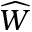<formula> <loc_0><loc_0><loc_500><loc_500>\widehat { W }</formula> 